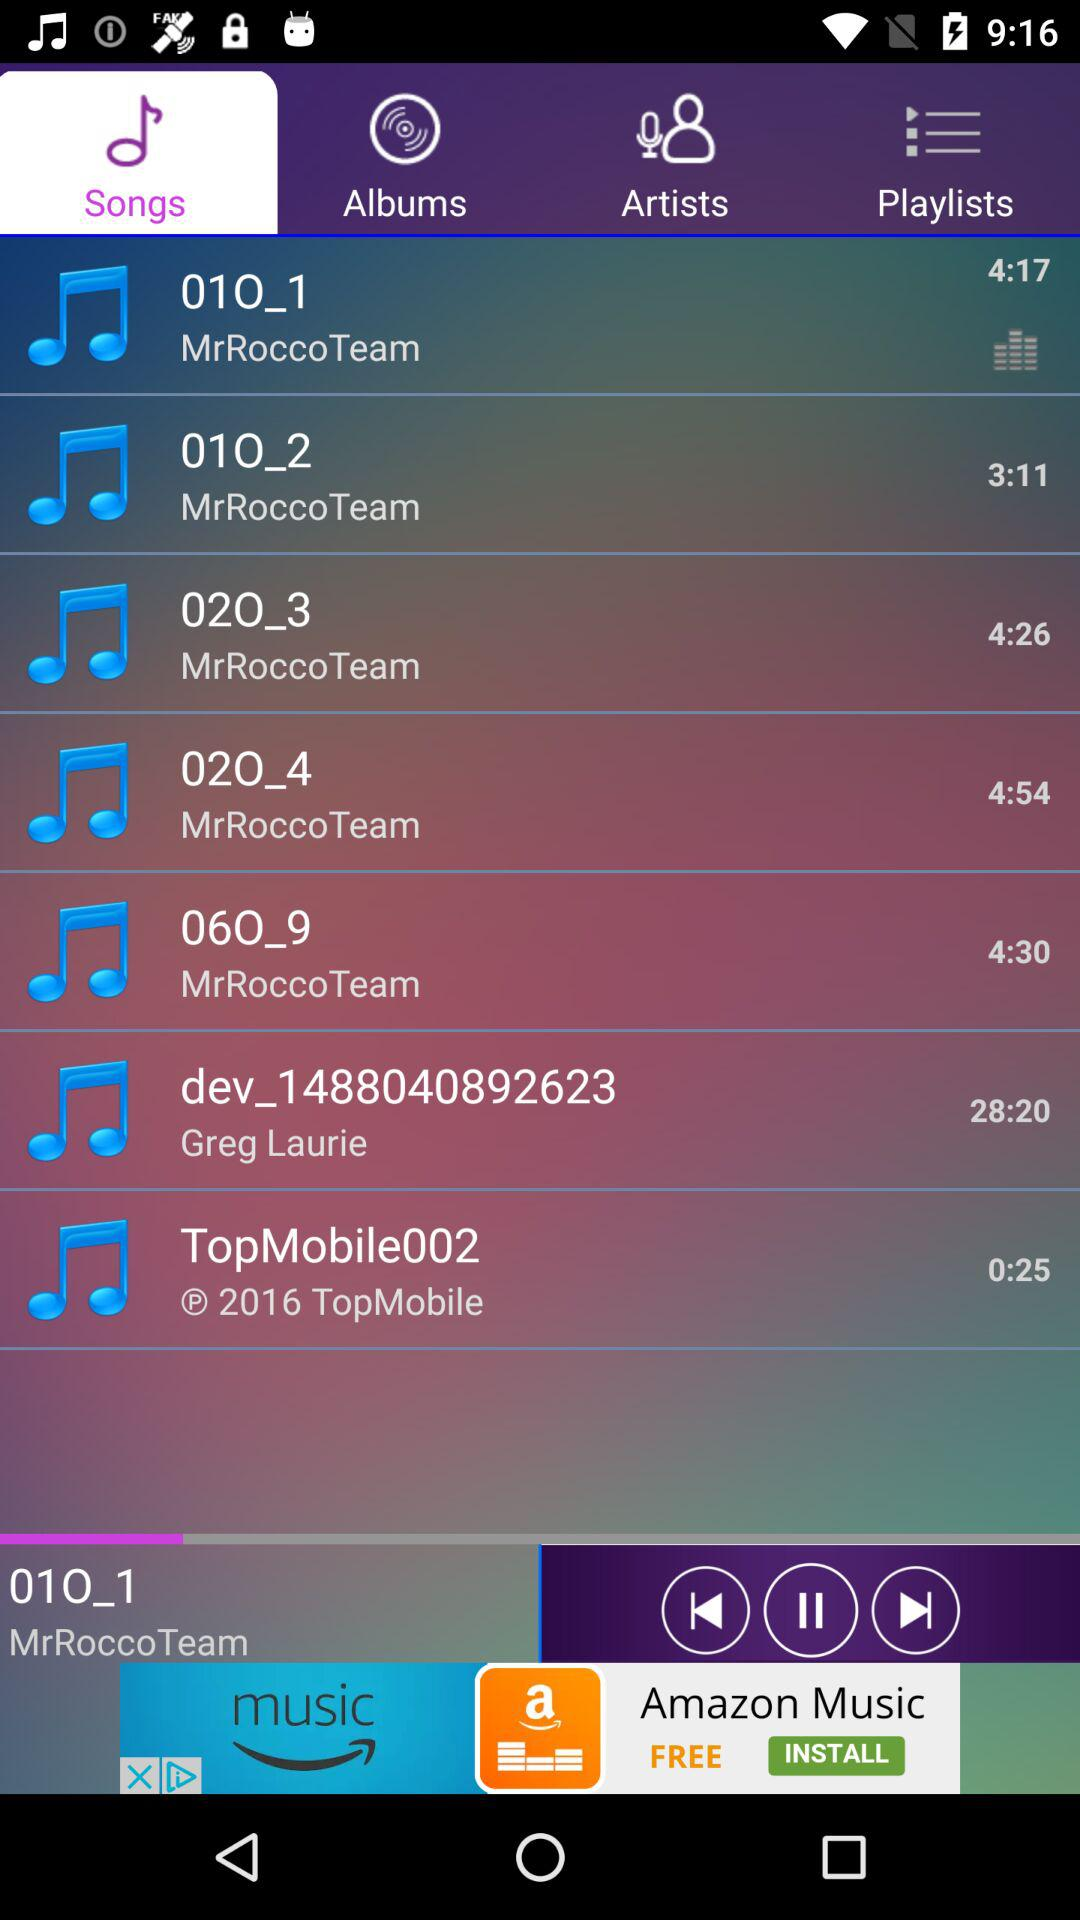What is the duration of the song named "01O_2"? The duration of the song is 3 minutes and 11 seconds. 